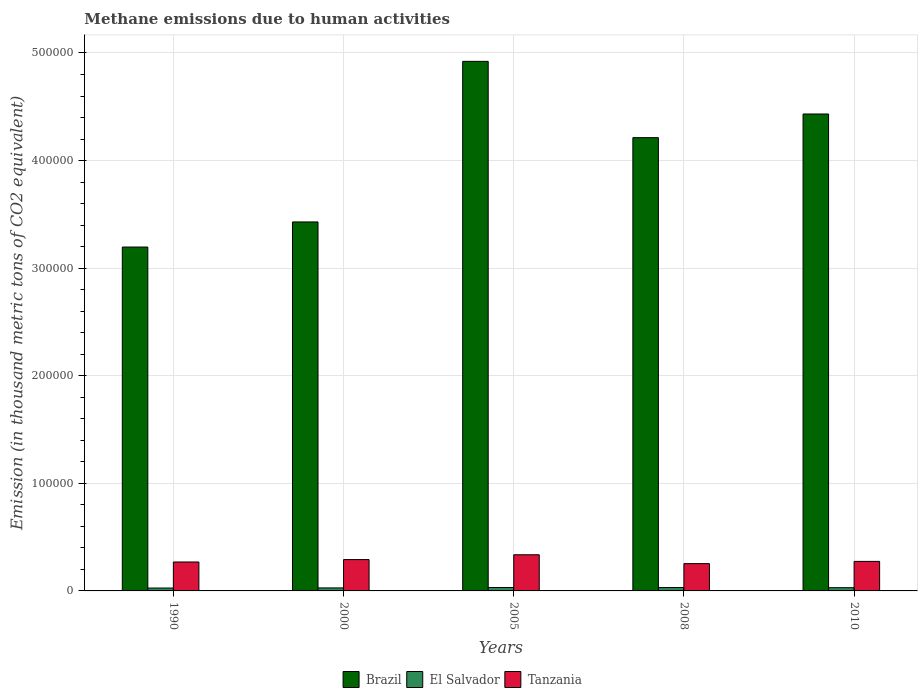How many different coloured bars are there?
Make the answer very short. 3. How many bars are there on the 3rd tick from the right?
Offer a terse response. 3. What is the label of the 1st group of bars from the left?
Offer a terse response. 1990. In how many cases, is the number of bars for a given year not equal to the number of legend labels?
Your answer should be compact. 0. What is the amount of methane emitted in Brazil in 2010?
Make the answer very short. 4.43e+05. Across all years, what is the maximum amount of methane emitted in Tanzania?
Your answer should be very brief. 3.36e+04. Across all years, what is the minimum amount of methane emitted in El Salvador?
Ensure brevity in your answer.  2672.9. In which year was the amount of methane emitted in El Salvador maximum?
Ensure brevity in your answer.  2005. In which year was the amount of methane emitted in El Salvador minimum?
Your answer should be compact. 1990. What is the total amount of methane emitted in Brazil in the graph?
Provide a succinct answer. 2.02e+06. What is the difference between the amount of methane emitted in Brazil in 2005 and that in 2008?
Make the answer very short. 7.09e+04. What is the difference between the amount of methane emitted in Tanzania in 2008 and the amount of methane emitted in El Salvador in 2005?
Provide a short and direct response. 2.22e+04. What is the average amount of methane emitted in El Salvador per year?
Offer a terse response. 2948.74. In the year 2005, what is the difference between the amount of methane emitted in El Salvador and amount of methane emitted in Brazil?
Your response must be concise. -4.89e+05. What is the ratio of the amount of methane emitted in El Salvador in 1990 to that in 2000?
Make the answer very short. 0.96. Is the difference between the amount of methane emitted in El Salvador in 1990 and 2008 greater than the difference between the amount of methane emitted in Brazil in 1990 and 2008?
Your answer should be compact. Yes. What is the difference between the highest and the second highest amount of methane emitted in El Salvador?
Offer a terse response. 25.1. What is the difference between the highest and the lowest amount of methane emitted in El Salvador?
Provide a short and direct response. 479.9. In how many years, is the amount of methane emitted in Brazil greater than the average amount of methane emitted in Brazil taken over all years?
Keep it short and to the point. 3. What does the 1st bar from the left in 1990 represents?
Your answer should be very brief. Brazil. What does the 2nd bar from the right in 2008 represents?
Provide a short and direct response. El Salvador. Is it the case that in every year, the sum of the amount of methane emitted in Tanzania and amount of methane emitted in Brazil is greater than the amount of methane emitted in El Salvador?
Keep it short and to the point. Yes. Does the graph contain any zero values?
Ensure brevity in your answer.  No. Does the graph contain grids?
Give a very brief answer. Yes. Where does the legend appear in the graph?
Give a very brief answer. Bottom center. What is the title of the graph?
Make the answer very short. Methane emissions due to human activities. Does "Sub-Saharan Africa (all income levels)" appear as one of the legend labels in the graph?
Provide a short and direct response. No. What is the label or title of the X-axis?
Give a very brief answer. Years. What is the label or title of the Y-axis?
Provide a succinct answer. Emission (in thousand metric tons of CO2 equivalent). What is the Emission (in thousand metric tons of CO2 equivalent) of Brazil in 1990?
Offer a very short reply. 3.20e+05. What is the Emission (in thousand metric tons of CO2 equivalent) in El Salvador in 1990?
Provide a succinct answer. 2672.9. What is the Emission (in thousand metric tons of CO2 equivalent) in Tanzania in 1990?
Provide a short and direct response. 2.69e+04. What is the Emission (in thousand metric tons of CO2 equivalent) in Brazil in 2000?
Offer a very short reply. 3.43e+05. What is the Emission (in thousand metric tons of CO2 equivalent) of El Salvador in 2000?
Your response must be concise. 2798.1. What is the Emission (in thousand metric tons of CO2 equivalent) of Tanzania in 2000?
Give a very brief answer. 2.91e+04. What is the Emission (in thousand metric tons of CO2 equivalent) of Brazil in 2005?
Give a very brief answer. 4.92e+05. What is the Emission (in thousand metric tons of CO2 equivalent) in El Salvador in 2005?
Your response must be concise. 3152.8. What is the Emission (in thousand metric tons of CO2 equivalent) of Tanzania in 2005?
Your response must be concise. 3.36e+04. What is the Emission (in thousand metric tons of CO2 equivalent) of Brazil in 2008?
Keep it short and to the point. 4.21e+05. What is the Emission (in thousand metric tons of CO2 equivalent) of El Salvador in 2008?
Give a very brief answer. 3127.7. What is the Emission (in thousand metric tons of CO2 equivalent) in Tanzania in 2008?
Your answer should be very brief. 2.54e+04. What is the Emission (in thousand metric tons of CO2 equivalent) in Brazil in 2010?
Your answer should be very brief. 4.43e+05. What is the Emission (in thousand metric tons of CO2 equivalent) of El Salvador in 2010?
Your answer should be compact. 2992.2. What is the Emission (in thousand metric tons of CO2 equivalent) in Tanzania in 2010?
Provide a succinct answer. 2.74e+04. Across all years, what is the maximum Emission (in thousand metric tons of CO2 equivalent) of Brazil?
Offer a terse response. 4.92e+05. Across all years, what is the maximum Emission (in thousand metric tons of CO2 equivalent) of El Salvador?
Your answer should be very brief. 3152.8. Across all years, what is the maximum Emission (in thousand metric tons of CO2 equivalent) of Tanzania?
Offer a very short reply. 3.36e+04. Across all years, what is the minimum Emission (in thousand metric tons of CO2 equivalent) in Brazil?
Offer a terse response. 3.20e+05. Across all years, what is the minimum Emission (in thousand metric tons of CO2 equivalent) of El Salvador?
Your answer should be very brief. 2672.9. Across all years, what is the minimum Emission (in thousand metric tons of CO2 equivalent) of Tanzania?
Your answer should be compact. 2.54e+04. What is the total Emission (in thousand metric tons of CO2 equivalent) in Brazil in the graph?
Make the answer very short. 2.02e+06. What is the total Emission (in thousand metric tons of CO2 equivalent) of El Salvador in the graph?
Offer a terse response. 1.47e+04. What is the total Emission (in thousand metric tons of CO2 equivalent) of Tanzania in the graph?
Offer a terse response. 1.42e+05. What is the difference between the Emission (in thousand metric tons of CO2 equivalent) of Brazil in 1990 and that in 2000?
Offer a terse response. -2.33e+04. What is the difference between the Emission (in thousand metric tons of CO2 equivalent) of El Salvador in 1990 and that in 2000?
Provide a short and direct response. -125.2. What is the difference between the Emission (in thousand metric tons of CO2 equivalent) of Tanzania in 1990 and that in 2000?
Your answer should be compact. -2232.7. What is the difference between the Emission (in thousand metric tons of CO2 equivalent) in Brazil in 1990 and that in 2005?
Provide a succinct answer. -1.73e+05. What is the difference between the Emission (in thousand metric tons of CO2 equivalent) of El Salvador in 1990 and that in 2005?
Provide a short and direct response. -479.9. What is the difference between the Emission (in thousand metric tons of CO2 equivalent) in Tanzania in 1990 and that in 2005?
Your answer should be compact. -6719. What is the difference between the Emission (in thousand metric tons of CO2 equivalent) of Brazil in 1990 and that in 2008?
Your answer should be compact. -1.02e+05. What is the difference between the Emission (in thousand metric tons of CO2 equivalent) of El Salvador in 1990 and that in 2008?
Keep it short and to the point. -454.8. What is the difference between the Emission (in thousand metric tons of CO2 equivalent) in Tanzania in 1990 and that in 2008?
Provide a succinct answer. 1531.3. What is the difference between the Emission (in thousand metric tons of CO2 equivalent) of Brazil in 1990 and that in 2010?
Offer a very short reply. -1.24e+05. What is the difference between the Emission (in thousand metric tons of CO2 equivalent) in El Salvador in 1990 and that in 2010?
Offer a terse response. -319.3. What is the difference between the Emission (in thousand metric tons of CO2 equivalent) in Tanzania in 1990 and that in 2010?
Provide a short and direct response. -554.2. What is the difference between the Emission (in thousand metric tons of CO2 equivalent) of Brazil in 2000 and that in 2005?
Keep it short and to the point. -1.49e+05. What is the difference between the Emission (in thousand metric tons of CO2 equivalent) in El Salvador in 2000 and that in 2005?
Ensure brevity in your answer.  -354.7. What is the difference between the Emission (in thousand metric tons of CO2 equivalent) of Tanzania in 2000 and that in 2005?
Offer a terse response. -4486.3. What is the difference between the Emission (in thousand metric tons of CO2 equivalent) of Brazil in 2000 and that in 2008?
Your answer should be very brief. -7.84e+04. What is the difference between the Emission (in thousand metric tons of CO2 equivalent) in El Salvador in 2000 and that in 2008?
Make the answer very short. -329.6. What is the difference between the Emission (in thousand metric tons of CO2 equivalent) of Tanzania in 2000 and that in 2008?
Your answer should be compact. 3764. What is the difference between the Emission (in thousand metric tons of CO2 equivalent) in Brazil in 2000 and that in 2010?
Provide a succinct answer. -1.00e+05. What is the difference between the Emission (in thousand metric tons of CO2 equivalent) in El Salvador in 2000 and that in 2010?
Offer a terse response. -194.1. What is the difference between the Emission (in thousand metric tons of CO2 equivalent) in Tanzania in 2000 and that in 2010?
Your answer should be compact. 1678.5. What is the difference between the Emission (in thousand metric tons of CO2 equivalent) of Brazil in 2005 and that in 2008?
Your answer should be very brief. 7.09e+04. What is the difference between the Emission (in thousand metric tons of CO2 equivalent) in El Salvador in 2005 and that in 2008?
Provide a succinct answer. 25.1. What is the difference between the Emission (in thousand metric tons of CO2 equivalent) of Tanzania in 2005 and that in 2008?
Ensure brevity in your answer.  8250.3. What is the difference between the Emission (in thousand metric tons of CO2 equivalent) in Brazil in 2005 and that in 2010?
Your answer should be very brief. 4.89e+04. What is the difference between the Emission (in thousand metric tons of CO2 equivalent) in El Salvador in 2005 and that in 2010?
Keep it short and to the point. 160.6. What is the difference between the Emission (in thousand metric tons of CO2 equivalent) in Tanzania in 2005 and that in 2010?
Provide a short and direct response. 6164.8. What is the difference between the Emission (in thousand metric tons of CO2 equivalent) of Brazil in 2008 and that in 2010?
Your answer should be very brief. -2.20e+04. What is the difference between the Emission (in thousand metric tons of CO2 equivalent) of El Salvador in 2008 and that in 2010?
Give a very brief answer. 135.5. What is the difference between the Emission (in thousand metric tons of CO2 equivalent) in Tanzania in 2008 and that in 2010?
Offer a very short reply. -2085.5. What is the difference between the Emission (in thousand metric tons of CO2 equivalent) in Brazil in 1990 and the Emission (in thousand metric tons of CO2 equivalent) in El Salvador in 2000?
Offer a terse response. 3.17e+05. What is the difference between the Emission (in thousand metric tons of CO2 equivalent) of Brazil in 1990 and the Emission (in thousand metric tons of CO2 equivalent) of Tanzania in 2000?
Provide a short and direct response. 2.91e+05. What is the difference between the Emission (in thousand metric tons of CO2 equivalent) in El Salvador in 1990 and the Emission (in thousand metric tons of CO2 equivalent) in Tanzania in 2000?
Give a very brief answer. -2.65e+04. What is the difference between the Emission (in thousand metric tons of CO2 equivalent) in Brazil in 1990 and the Emission (in thousand metric tons of CO2 equivalent) in El Salvador in 2005?
Offer a very short reply. 3.16e+05. What is the difference between the Emission (in thousand metric tons of CO2 equivalent) of Brazil in 1990 and the Emission (in thousand metric tons of CO2 equivalent) of Tanzania in 2005?
Your response must be concise. 2.86e+05. What is the difference between the Emission (in thousand metric tons of CO2 equivalent) in El Salvador in 1990 and the Emission (in thousand metric tons of CO2 equivalent) in Tanzania in 2005?
Give a very brief answer. -3.09e+04. What is the difference between the Emission (in thousand metric tons of CO2 equivalent) of Brazil in 1990 and the Emission (in thousand metric tons of CO2 equivalent) of El Salvador in 2008?
Offer a terse response. 3.17e+05. What is the difference between the Emission (in thousand metric tons of CO2 equivalent) in Brazil in 1990 and the Emission (in thousand metric tons of CO2 equivalent) in Tanzania in 2008?
Provide a short and direct response. 2.94e+05. What is the difference between the Emission (in thousand metric tons of CO2 equivalent) of El Salvador in 1990 and the Emission (in thousand metric tons of CO2 equivalent) of Tanzania in 2008?
Make the answer very short. -2.27e+04. What is the difference between the Emission (in thousand metric tons of CO2 equivalent) of Brazil in 1990 and the Emission (in thousand metric tons of CO2 equivalent) of El Salvador in 2010?
Ensure brevity in your answer.  3.17e+05. What is the difference between the Emission (in thousand metric tons of CO2 equivalent) of Brazil in 1990 and the Emission (in thousand metric tons of CO2 equivalent) of Tanzania in 2010?
Keep it short and to the point. 2.92e+05. What is the difference between the Emission (in thousand metric tons of CO2 equivalent) of El Salvador in 1990 and the Emission (in thousand metric tons of CO2 equivalent) of Tanzania in 2010?
Ensure brevity in your answer.  -2.48e+04. What is the difference between the Emission (in thousand metric tons of CO2 equivalent) in Brazil in 2000 and the Emission (in thousand metric tons of CO2 equivalent) in El Salvador in 2005?
Provide a short and direct response. 3.40e+05. What is the difference between the Emission (in thousand metric tons of CO2 equivalent) in Brazil in 2000 and the Emission (in thousand metric tons of CO2 equivalent) in Tanzania in 2005?
Offer a very short reply. 3.09e+05. What is the difference between the Emission (in thousand metric tons of CO2 equivalent) in El Salvador in 2000 and the Emission (in thousand metric tons of CO2 equivalent) in Tanzania in 2005?
Provide a short and direct response. -3.08e+04. What is the difference between the Emission (in thousand metric tons of CO2 equivalent) in Brazil in 2000 and the Emission (in thousand metric tons of CO2 equivalent) in El Salvador in 2008?
Your response must be concise. 3.40e+05. What is the difference between the Emission (in thousand metric tons of CO2 equivalent) in Brazil in 2000 and the Emission (in thousand metric tons of CO2 equivalent) in Tanzania in 2008?
Provide a succinct answer. 3.18e+05. What is the difference between the Emission (in thousand metric tons of CO2 equivalent) of El Salvador in 2000 and the Emission (in thousand metric tons of CO2 equivalent) of Tanzania in 2008?
Ensure brevity in your answer.  -2.26e+04. What is the difference between the Emission (in thousand metric tons of CO2 equivalent) in Brazil in 2000 and the Emission (in thousand metric tons of CO2 equivalent) in El Salvador in 2010?
Keep it short and to the point. 3.40e+05. What is the difference between the Emission (in thousand metric tons of CO2 equivalent) of Brazil in 2000 and the Emission (in thousand metric tons of CO2 equivalent) of Tanzania in 2010?
Provide a succinct answer. 3.16e+05. What is the difference between the Emission (in thousand metric tons of CO2 equivalent) of El Salvador in 2000 and the Emission (in thousand metric tons of CO2 equivalent) of Tanzania in 2010?
Provide a short and direct response. -2.46e+04. What is the difference between the Emission (in thousand metric tons of CO2 equivalent) in Brazil in 2005 and the Emission (in thousand metric tons of CO2 equivalent) in El Salvador in 2008?
Your answer should be very brief. 4.89e+05. What is the difference between the Emission (in thousand metric tons of CO2 equivalent) of Brazil in 2005 and the Emission (in thousand metric tons of CO2 equivalent) of Tanzania in 2008?
Provide a short and direct response. 4.67e+05. What is the difference between the Emission (in thousand metric tons of CO2 equivalent) in El Salvador in 2005 and the Emission (in thousand metric tons of CO2 equivalent) in Tanzania in 2008?
Provide a succinct answer. -2.22e+04. What is the difference between the Emission (in thousand metric tons of CO2 equivalent) of Brazil in 2005 and the Emission (in thousand metric tons of CO2 equivalent) of El Salvador in 2010?
Provide a succinct answer. 4.89e+05. What is the difference between the Emission (in thousand metric tons of CO2 equivalent) of Brazil in 2005 and the Emission (in thousand metric tons of CO2 equivalent) of Tanzania in 2010?
Offer a terse response. 4.65e+05. What is the difference between the Emission (in thousand metric tons of CO2 equivalent) in El Salvador in 2005 and the Emission (in thousand metric tons of CO2 equivalent) in Tanzania in 2010?
Keep it short and to the point. -2.43e+04. What is the difference between the Emission (in thousand metric tons of CO2 equivalent) in Brazil in 2008 and the Emission (in thousand metric tons of CO2 equivalent) in El Salvador in 2010?
Give a very brief answer. 4.18e+05. What is the difference between the Emission (in thousand metric tons of CO2 equivalent) of Brazil in 2008 and the Emission (in thousand metric tons of CO2 equivalent) of Tanzania in 2010?
Make the answer very short. 3.94e+05. What is the difference between the Emission (in thousand metric tons of CO2 equivalent) of El Salvador in 2008 and the Emission (in thousand metric tons of CO2 equivalent) of Tanzania in 2010?
Provide a short and direct response. -2.43e+04. What is the average Emission (in thousand metric tons of CO2 equivalent) of Brazil per year?
Keep it short and to the point. 4.04e+05. What is the average Emission (in thousand metric tons of CO2 equivalent) of El Salvador per year?
Give a very brief answer. 2948.74. What is the average Emission (in thousand metric tons of CO2 equivalent) in Tanzania per year?
Your response must be concise. 2.85e+04. In the year 1990, what is the difference between the Emission (in thousand metric tons of CO2 equivalent) of Brazil and Emission (in thousand metric tons of CO2 equivalent) of El Salvador?
Provide a succinct answer. 3.17e+05. In the year 1990, what is the difference between the Emission (in thousand metric tons of CO2 equivalent) of Brazil and Emission (in thousand metric tons of CO2 equivalent) of Tanzania?
Keep it short and to the point. 2.93e+05. In the year 1990, what is the difference between the Emission (in thousand metric tons of CO2 equivalent) of El Salvador and Emission (in thousand metric tons of CO2 equivalent) of Tanzania?
Offer a very short reply. -2.42e+04. In the year 2000, what is the difference between the Emission (in thousand metric tons of CO2 equivalent) in Brazil and Emission (in thousand metric tons of CO2 equivalent) in El Salvador?
Give a very brief answer. 3.40e+05. In the year 2000, what is the difference between the Emission (in thousand metric tons of CO2 equivalent) in Brazil and Emission (in thousand metric tons of CO2 equivalent) in Tanzania?
Provide a short and direct response. 3.14e+05. In the year 2000, what is the difference between the Emission (in thousand metric tons of CO2 equivalent) in El Salvador and Emission (in thousand metric tons of CO2 equivalent) in Tanzania?
Your answer should be very brief. -2.63e+04. In the year 2005, what is the difference between the Emission (in thousand metric tons of CO2 equivalent) in Brazil and Emission (in thousand metric tons of CO2 equivalent) in El Salvador?
Offer a terse response. 4.89e+05. In the year 2005, what is the difference between the Emission (in thousand metric tons of CO2 equivalent) in Brazil and Emission (in thousand metric tons of CO2 equivalent) in Tanzania?
Offer a very short reply. 4.59e+05. In the year 2005, what is the difference between the Emission (in thousand metric tons of CO2 equivalent) in El Salvador and Emission (in thousand metric tons of CO2 equivalent) in Tanzania?
Keep it short and to the point. -3.05e+04. In the year 2008, what is the difference between the Emission (in thousand metric tons of CO2 equivalent) in Brazil and Emission (in thousand metric tons of CO2 equivalent) in El Salvador?
Keep it short and to the point. 4.18e+05. In the year 2008, what is the difference between the Emission (in thousand metric tons of CO2 equivalent) in Brazil and Emission (in thousand metric tons of CO2 equivalent) in Tanzania?
Your answer should be compact. 3.96e+05. In the year 2008, what is the difference between the Emission (in thousand metric tons of CO2 equivalent) of El Salvador and Emission (in thousand metric tons of CO2 equivalent) of Tanzania?
Provide a succinct answer. -2.22e+04. In the year 2010, what is the difference between the Emission (in thousand metric tons of CO2 equivalent) in Brazil and Emission (in thousand metric tons of CO2 equivalent) in El Salvador?
Give a very brief answer. 4.40e+05. In the year 2010, what is the difference between the Emission (in thousand metric tons of CO2 equivalent) of Brazil and Emission (in thousand metric tons of CO2 equivalent) of Tanzania?
Offer a terse response. 4.16e+05. In the year 2010, what is the difference between the Emission (in thousand metric tons of CO2 equivalent) of El Salvador and Emission (in thousand metric tons of CO2 equivalent) of Tanzania?
Ensure brevity in your answer.  -2.45e+04. What is the ratio of the Emission (in thousand metric tons of CO2 equivalent) in Brazil in 1990 to that in 2000?
Provide a succinct answer. 0.93. What is the ratio of the Emission (in thousand metric tons of CO2 equivalent) of El Salvador in 1990 to that in 2000?
Provide a succinct answer. 0.96. What is the ratio of the Emission (in thousand metric tons of CO2 equivalent) in Tanzania in 1990 to that in 2000?
Your answer should be compact. 0.92. What is the ratio of the Emission (in thousand metric tons of CO2 equivalent) of Brazil in 1990 to that in 2005?
Offer a terse response. 0.65. What is the ratio of the Emission (in thousand metric tons of CO2 equivalent) of El Salvador in 1990 to that in 2005?
Give a very brief answer. 0.85. What is the ratio of the Emission (in thousand metric tons of CO2 equivalent) in Tanzania in 1990 to that in 2005?
Provide a short and direct response. 0.8. What is the ratio of the Emission (in thousand metric tons of CO2 equivalent) in Brazil in 1990 to that in 2008?
Your response must be concise. 0.76. What is the ratio of the Emission (in thousand metric tons of CO2 equivalent) of El Salvador in 1990 to that in 2008?
Offer a very short reply. 0.85. What is the ratio of the Emission (in thousand metric tons of CO2 equivalent) in Tanzania in 1990 to that in 2008?
Ensure brevity in your answer.  1.06. What is the ratio of the Emission (in thousand metric tons of CO2 equivalent) in Brazil in 1990 to that in 2010?
Your answer should be compact. 0.72. What is the ratio of the Emission (in thousand metric tons of CO2 equivalent) of El Salvador in 1990 to that in 2010?
Give a very brief answer. 0.89. What is the ratio of the Emission (in thousand metric tons of CO2 equivalent) in Tanzania in 1990 to that in 2010?
Your answer should be very brief. 0.98. What is the ratio of the Emission (in thousand metric tons of CO2 equivalent) in Brazil in 2000 to that in 2005?
Provide a short and direct response. 0.7. What is the ratio of the Emission (in thousand metric tons of CO2 equivalent) of El Salvador in 2000 to that in 2005?
Keep it short and to the point. 0.89. What is the ratio of the Emission (in thousand metric tons of CO2 equivalent) in Tanzania in 2000 to that in 2005?
Make the answer very short. 0.87. What is the ratio of the Emission (in thousand metric tons of CO2 equivalent) in Brazil in 2000 to that in 2008?
Give a very brief answer. 0.81. What is the ratio of the Emission (in thousand metric tons of CO2 equivalent) in El Salvador in 2000 to that in 2008?
Your answer should be compact. 0.89. What is the ratio of the Emission (in thousand metric tons of CO2 equivalent) in Tanzania in 2000 to that in 2008?
Ensure brevity in your answer.  1.15. What is the ratio of the Emission (in thousand metric tons of CO2 equivalent) in Brazil in 2000 to that in 2010?
Offer a very short reply. 0.77. What is the ratio of the Emission (in thousand metric tons of CO2 equivalent) in El Salvador in 2000 to that in 2010?
Keep it short and to the point. 0.94. What is the ratio of the Emission (in thousand metric tons of CO2 equivalent) in Tanzania in 2000 to that in 2010?
Give a very brief answer. 1.06. What is the ratio of the Emission (in thousand metric tons of CO2 equivalent) in Brazil in 2005 to that in 2008?
Offer a terse response. 1.17. What is the ratio of the Emission (in thousand metric tons of CO2 equivalent) of Tanzania in 2005 to that in 2008?
Your answer should be compact. 1.33. What is the ratio of the Emission (in thousand metric tons of CO2 equivalent) in Brazil in 2005 to that in 2010?
Keep it short and to the point. 1.11. What is the ratio of the Emission (in thousand metric tons of CO2 equivalent) of El Salvador in 2005 to that in 2010?
Give a very brief answer. 1.05. What is the ratio of the Emission (in thousand metric tons of CO2 equivalent) of Tanzania in 2005 to that in 2010?
Provide a short and direct response. 1.22. What is the ratio of the Emission (in thousand metric tons of CO2 equivalent) of Brazil in 2008 to that in 2010?
Keep it short and to the point. 0.95. What is the ratio of the Emission (in thousand metric tons of CO2 equivalent) of El Salvador in 2008 to that in 2010?
Keep it short and to the point. 1.05. What is the ratio of the Emission (in thousand metric tons of CO2 equivalent) of Tanzania in 2008 to that in 2010?
Offer a very short reply. 0.92. What is the difference between the highest and the second highest Emission (in thousand metric tons of CO2 equivalent) of Brazil?
Your answer should be compact. 4.89e+04. What is the difference between the highest and the second highest Emission (in thousand metric tons of CO2 equivalent) in El Salvador?
Offer a very short reply. 25.1. What is the difference between the highest and the second highest Emission (in thousand metric tons of CO2 equivalent) of Tanzania?
Your answer should be compact. 4486.3. What is the difference between the highest and the lowest Emission (in thousand metric tons of CO2 equivalent) of Brazil?
Keep it short and to the point. 1.73e+05. What is the difference between the highest and the lowest Emission (in thousand metric tons of CO2 equivalent) in El Salvador?
Your response must be concise. 479.9. What is the difference between the highest and the lowest Emission (in thousand metric tons of CO2 equivalent) of Tanzania?
Your response must be concise. 8250.3. 